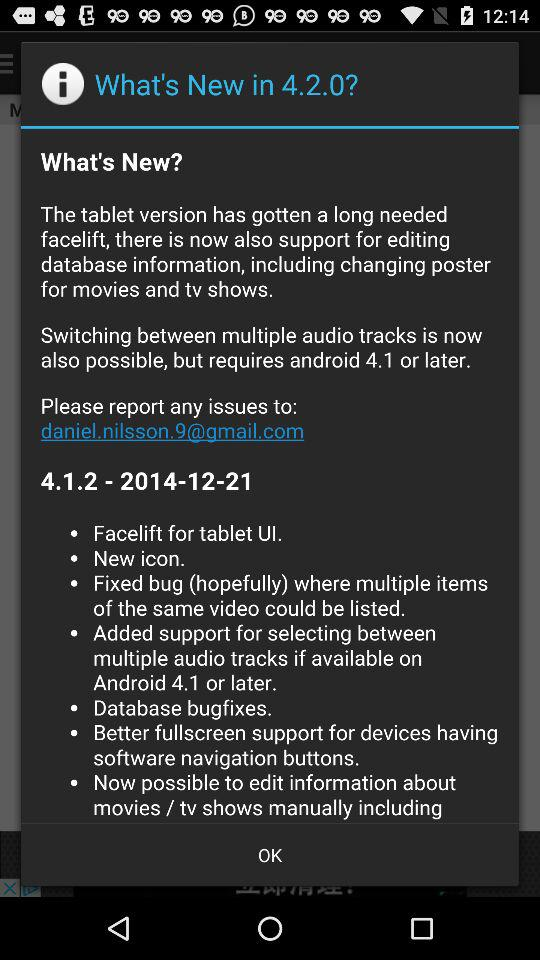What is the version of the application? The versions of the application are 4.2.0 and 4.1.2. 